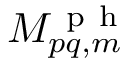Convert formula to latex. <formula><loc_0><loc_0><loc_500><loc_500>M _ { p q , m } ^ { p h }</formula> 